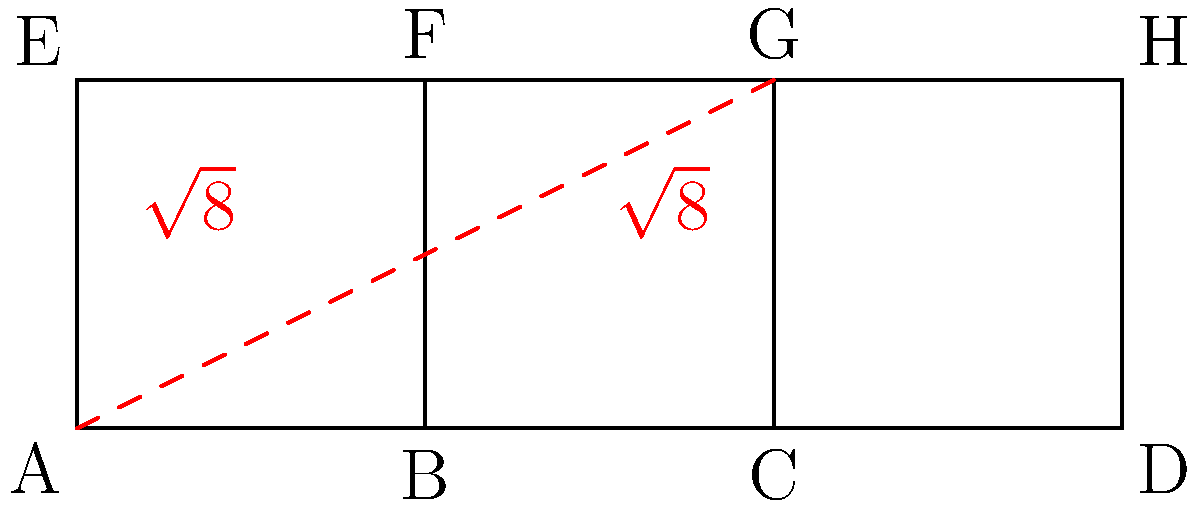In the context of AI path-planning algorithms, consider an unfolded cube as shown in the diagram. What is the shortest distance between points A and G on the surface of the cube when it is folded back into its 3D form? To solve this problem, we need to consider how the cube folds and the possible paths between A and G. Here's a step-by-step approach:

1) In the unfolded state, we see that A and G are diagonally opposite corners of a 2x2 square.

2) When the cube is folded, there are two possible paths:
   a) Along the face containing A, then across an adjacent face to G.
   b) Directly across the face diagonal from A to G.

3) Path a would involve traveling 2 units along one edge, then 2 units along another edge, totaling 4 units.

4) Path b, the diagonal, can be calculated using the Pythagorean theorem:
   $$d = \sqrt{2^2 + 2^2} = \sqrt{8} \approx 2.83$$

5) The diagonal path (b) is shorter than the edge path (a).

6) This diagonal path represents the hypotenuse of a right triangle formed on the surface of the cube, with the other two sides being edges of the cube.

7) In AI path-planning, this demonstrates the importance of considering three-dimensional space and geometric shortcuts, even when working with seemingly two-dimensional representations.

Therefore, the shortest path between A and G on the folded cube is the diagonal path with length $\sqrt{8}$.
Answer: $\sqrt{8}$ 